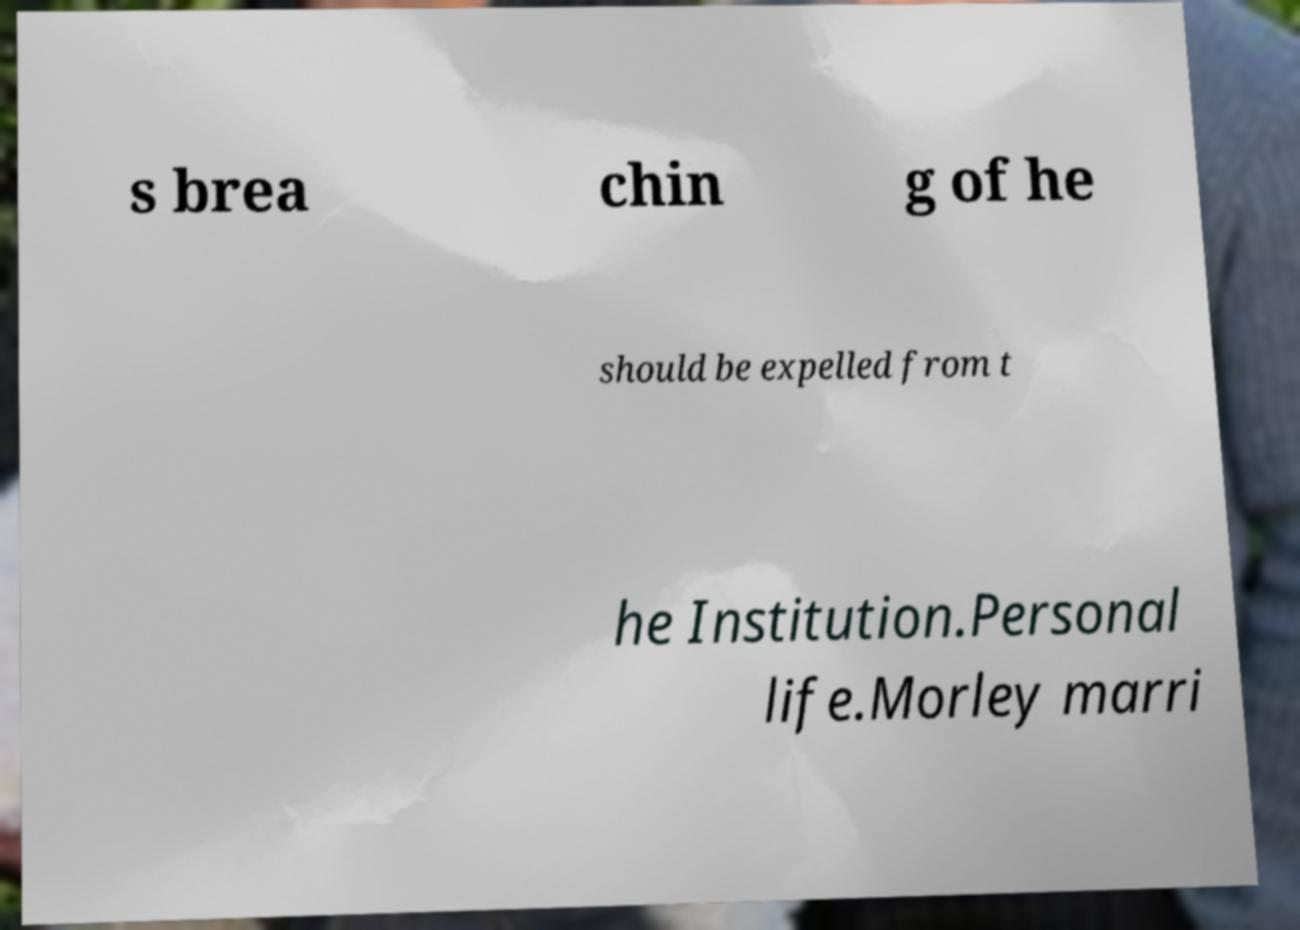There's text embedded in this image that I need extracted. Can you transcribe it verbatim? s brea chin g of he should be expelled from t he Institution.Personal life.Morley marri 